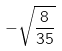<formula> <loc_0><loc_0><loc_500><loc_500>- \sqrt { \frac { 8 } { 3 5 } }</formula> 